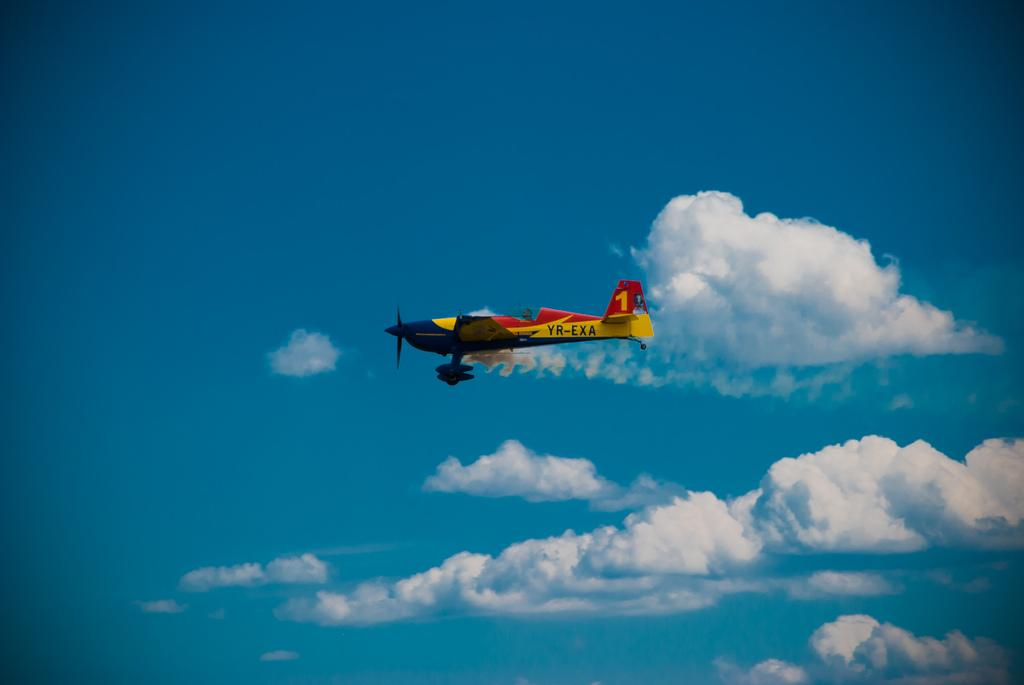What is flying in the sky in the image? There is a glider in the sky in the image. What can be seen in the background of the image? There are clouds visible in the background of the image. What type of nail is being used to hold the glider together in the image? There is no nail present in the image, as the glider is flying in the sky. 